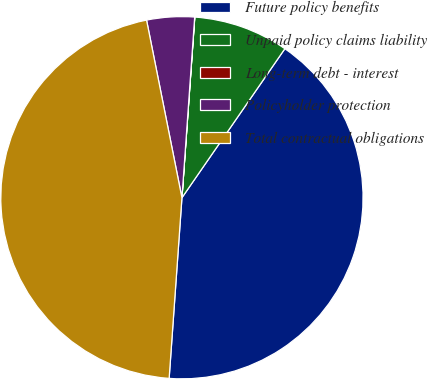Convert chart to OTSL. <chart><loc_0><loc_0><loc_500><loc_500><pie_chart><fcel>Future policy benefits<fcel>Unpaid policy claims liability<fcel>Long-term debt - interest<fcel>Policyholder protection<fcel>Total contractual obligations<nl><fcel>41.5%<fcel>8.49%<fcel>0.01%<fcel>4.25%<fcel>45.74%<nl></chart> 